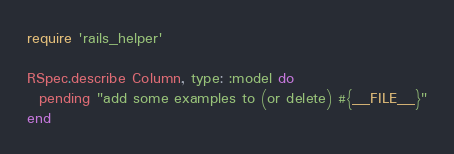Convert code to text. <code><loc_0><loc_0><loc_500><loc_500><_Ruby_>require 'rails_helper'

RSpec.describe Column, type: :model do
  pending "add some examples to (or delete) #{__FILE__}"
end
</code> 